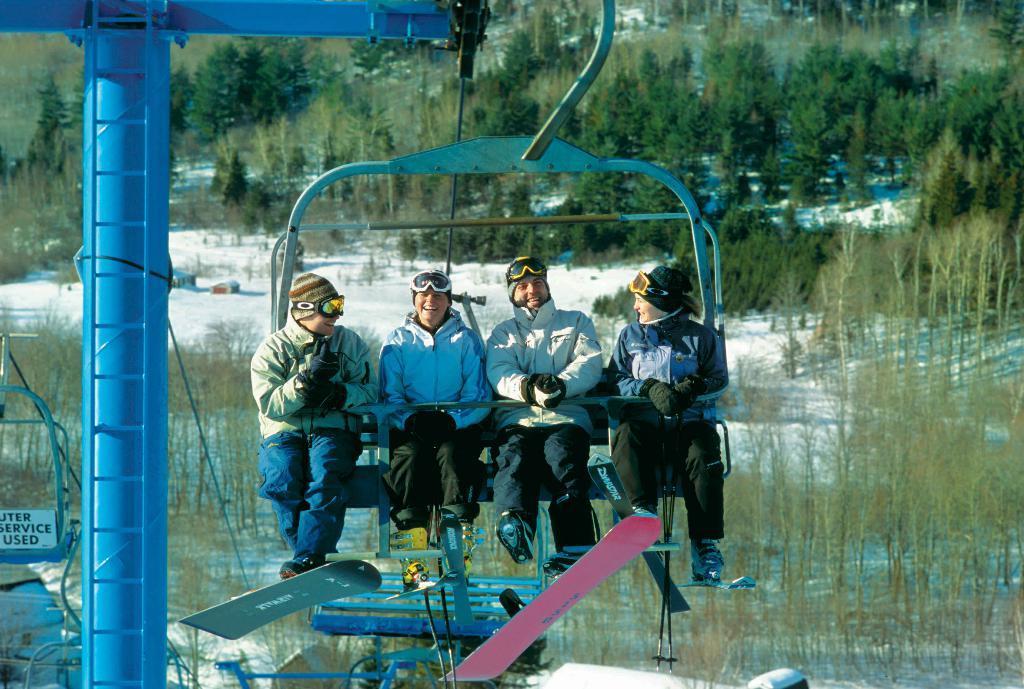How would you summarize this image in a sentence or two? In the image in the center we can see ski lift and sign board. On the ski lift,we can see four persons were sitting and they were smiling ,which we can see on their faces. In the background we can see trees and snow. 